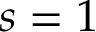<formula> <loc_0><loc_0><loc_500><loc_500>s = 1</formula> 